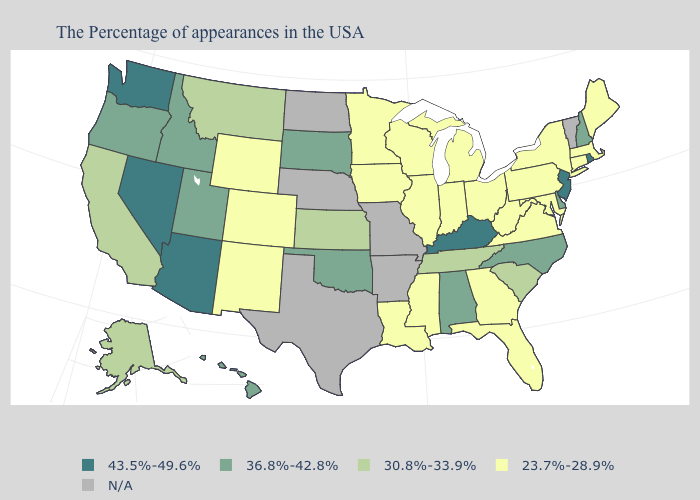Name the states that have a value in the range 23.7%-28.9%?
Write a very short answer. Maine, Massachusetts, Connecticut, New York, Maryland, Pennsylvania, Virginia, West Virginia, Ohio, Florida, Georgia, Michigan, Indiana, Wisconsin, Illinois, Mississippi, Louisiana, Minnesota, Iowa, Wyoming, Colorado, New Mexico. What is the highest value in the West ?
Keep it brief. 43.5%-49.6%. Does Georgia have the lowest value in the USA?
Keep it brief. Yes. Which states hav the highest value in the West?
Give a very brief answer. Arizona, Nevada, Washington. Name the states that have a value in the range N/A?
Give a very brief answer. Vermont, Missouri, Arkansas, Nebraska, Texas, North Dakota. Which states have the highest value in the USA?
Be succinct. Rhode Island, New Jersey, Kentucky, Arizona, Nevada, Washington. What is the highest value in the USA?
Answer briefly. 43.5%-49.6%. Among the states that border Massachusetts , does Rhode Island have the lowest value?
Keep it brief. No. What is the value of Massachusetts?
Keep it brief. 23.7%-28.9%. What is the value of Florida?
Be succinct. 23.7%-28.9%. Does Kentucky have the highest value in the South?
Give a very brief answer. Yes. Name the states that have a value in the range 30.8%-33.9%?
Answer briefly. South Carolina, Tennessee, Kansas, Montana, California, Alaska. Does New York have the highest value in the USA?
Write a very short answer. No. Name the states that have a value in the range 23.7%-28.9%?
Write a very short answer. Maine, Massachusetts, Connecticut, New York, Maryland, Pennsylvania, Virginia, West Virginia, Ohio, Florida, Georgia, Michigan, Indiana, Wisconsin, Illinois, Mississippi, Louisiana, Minnesota, Iowa, Wyoming, Colorado, New Mexico. 